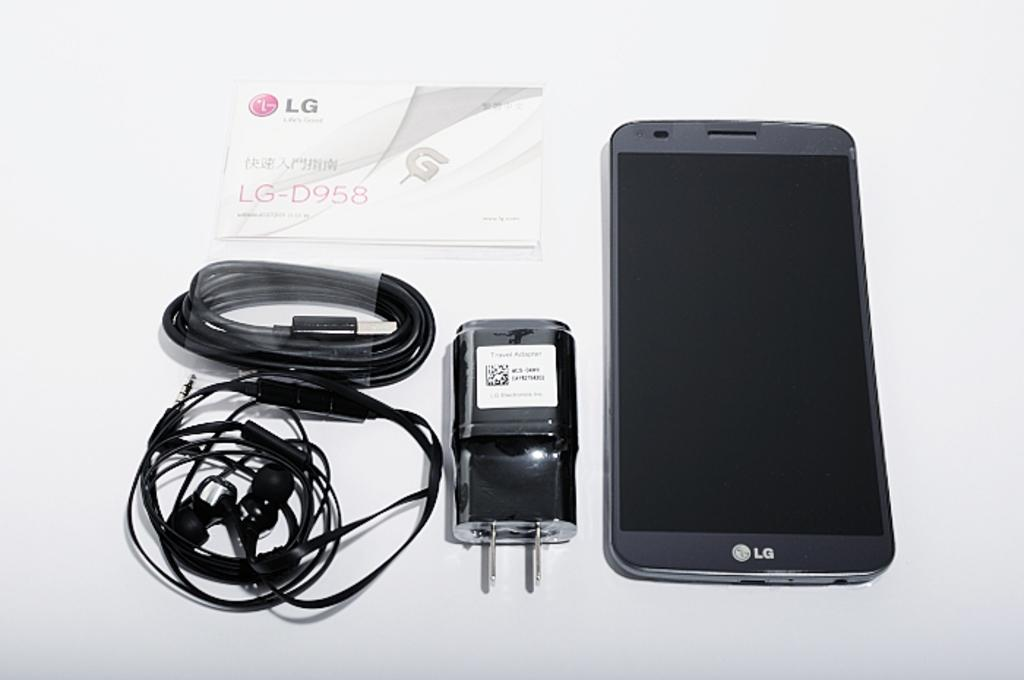Provide a one-sentence caption for the provided image. An LG phone lays on a table next to a travel adapter. 